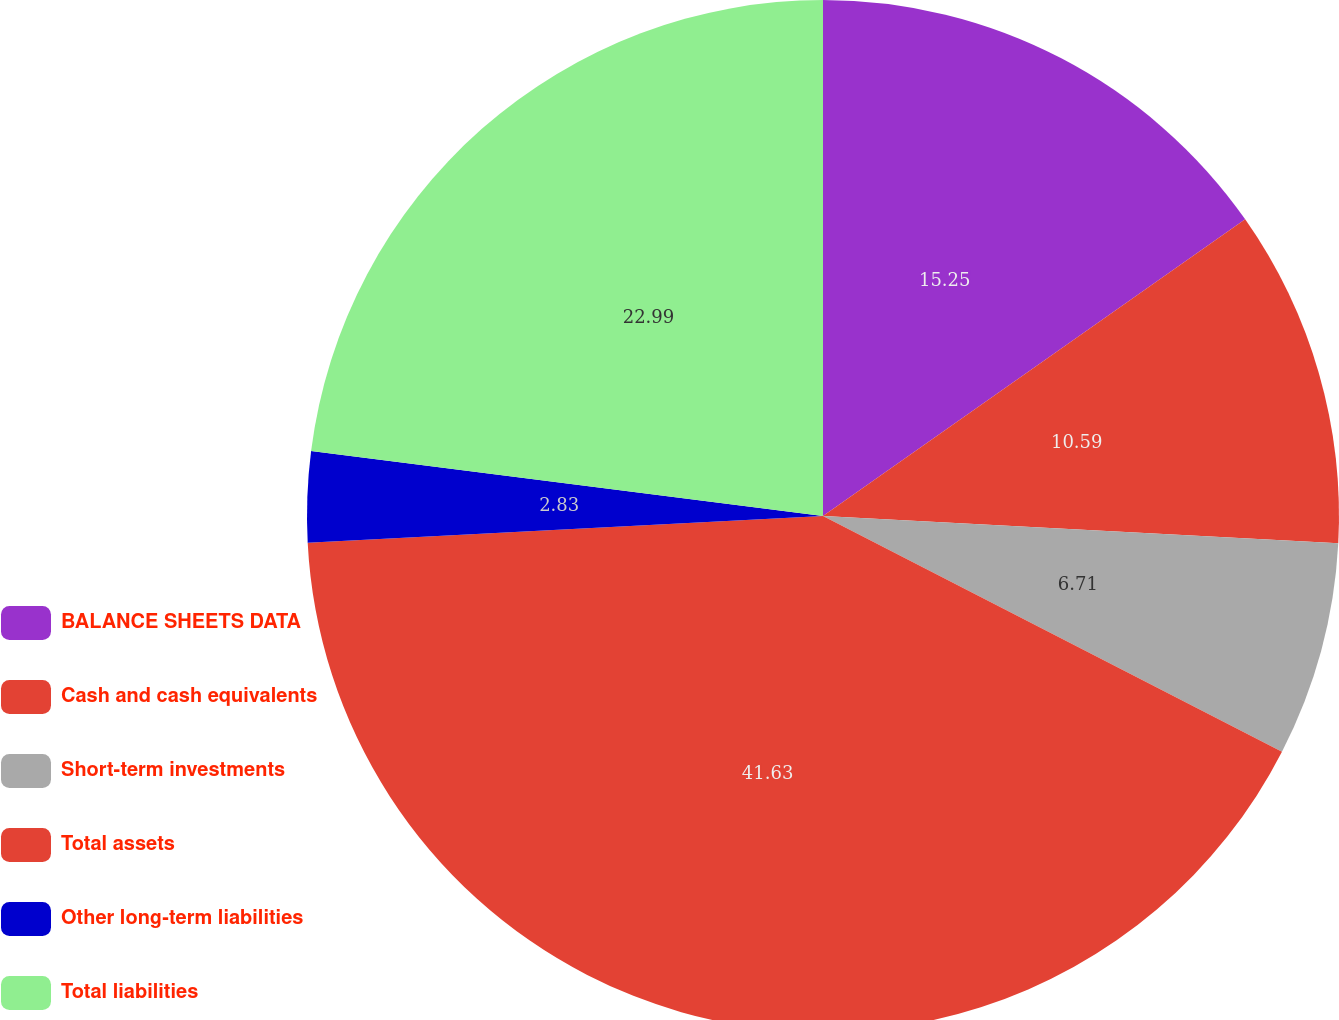Convert chart. <chart><loc_0><loc_0><loc_500><loc_500><pie_chart><fcel>BALANCE SHEETS DATA<fcel>Cash and cash equivalents<fcel>Short-term investments<fcel>Total assets<fcel>Other long-term liabilities<fcel>Total liabilities<nl><fcel>15.25%<fcel>10.59%<fcel>6.71%<fcel>41.62%<fcel>2.83%<fcel>22.99%<nl></chart> 